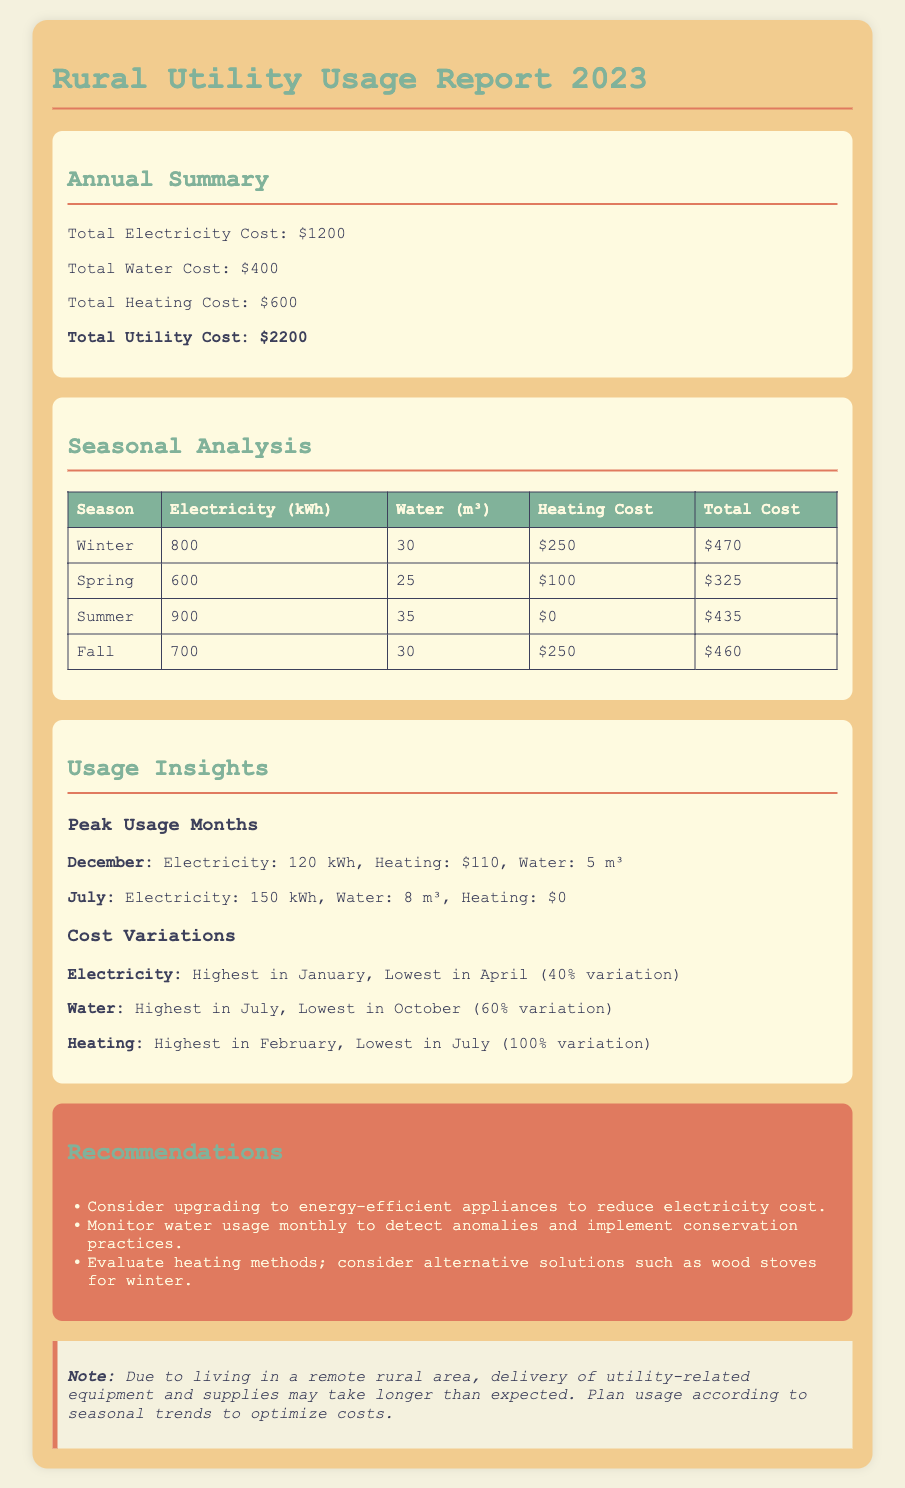What is the total electricity cost? The total electricity cost is stated in the annual summary of the report.
Answer: $1200 What season had the highest heating cost? The highest heating cost is noted in the winter and fall sections of the seasonal analysis.
Answer: Winter What is the total utility cost? The total utility cost is the sum of all utility expenses mentioned in the annual summary.
Answer: $2200 Which month had the peak electricity usage? The peak electricity usage month is listed in the usage insights section, specifically highlighting December.
Answer: December What is the highest water usage recorded? The highest water usage is found in the seasonal analysis, particularly in the summer.
Answer: 35 m³ Which season had no heating cost? The seasonal analysis indicates that there was no heating cost in one specific season.
Answer: Summer What percentage variation was noted for electricity costs? The document presents variations in costs as percentages in the cost variations section.
Answer: 40% What is recommended to reduce electricity cost? The recommendations section includes suggestions for appliances to mitigate electricity expenses.
Answer: Energy-efficient appliances What month had the lowest water usage? The lowest water usage is discussed in the usage insights about water variations.
Answer: October 